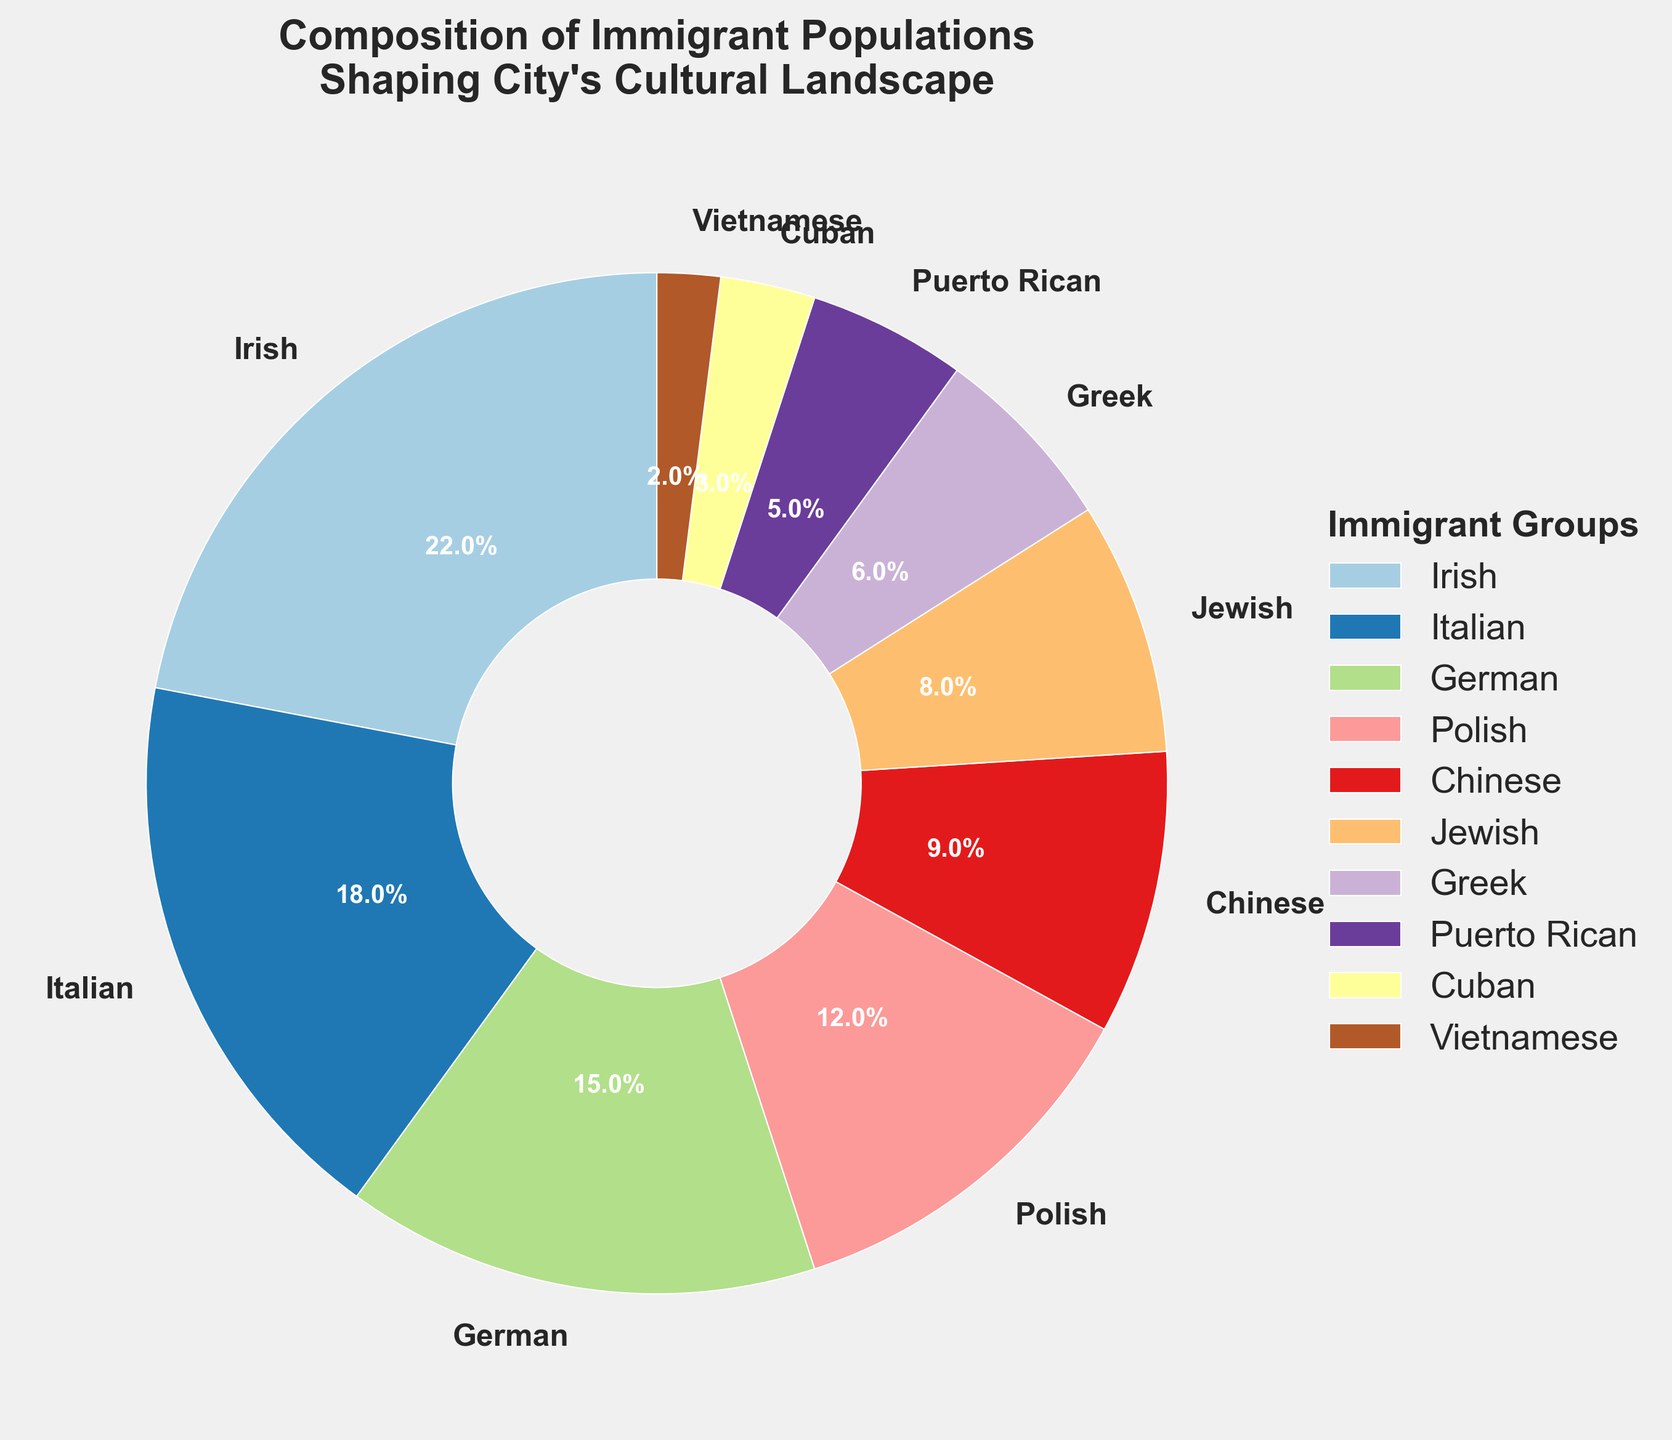What percentage of the immigrant population is made up of Irish and Italian groups combined? To determine this, add the percentage of the Irish group (22%) to the percentage of the Italian group (18%): 22% + 18% = 40%.
Answer: 40% Which immigrant group has a higher percentage, Polish or Chinese? Compare the percentages: Polish has 12%, and Chinese has 9%. Since 12% is greater than 9%, the Polish group has a higher percentage.
Answer: Polish What is the total percentage of the immigrant groups with less than 10% representation each? Add the percentages of the groups with less than 10%: Chinese (9%) + Jewish (8%) + Greek (6%) + Puerto Rican (5%) + Cuban (3%) + Vietnamese (2%) = 33%.
Answer: 33% How much larger is the Irish group compared to the German group in terms of percentage points? Subtract the percentage of the German group from the percentage of the Irish group: 22% - 15% = 7%.
Answer: 7% Which color represents the Italian immigrant group on the pie chart? By examining the color-coded segments of the pie chart, identify the segment labeled "Italian" and note its color.
Answer: The specific color, identifiable from the chart legend Between the Greek and Puerto Rican groups, which one has a smaller slice and by how much? Compare the percentages: Greek has 6%, and Puerto Rican has 5%. Calculate the difference: 6% - 5% = 1%.
Answer: Puerto Rican, by 1% What is the average percentage of the top three immigrant groups? Sum the percentages of the top three groups (Irish, Italian, German): 22% + 18% + 15% = 55%, then divide by 3: 55% / 3 ≈ 18.33%.
Answer: 18.33% If you combine the percentages of the Jewish and Cuban groups, do they make up more or less than the Greek group? Add the percentages of the Jewish (8%) and Cuban (3%) groups: 8% + 3% = 11%. Compare this with the Greek group's 6%: 11% is greater than 6%.
Answer: More What is the difference in the percentage of the Jewish group compared to the Vietnamese group? Subtract the percentage of the Vietnamese group from the percentage of the Jewish group: 8% - 2% = 6%.
Answer: 6% 